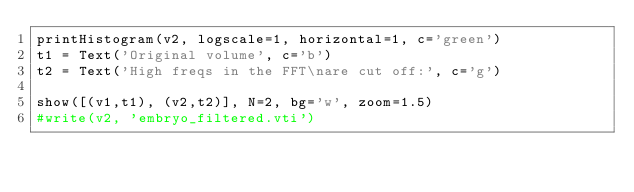<code> <loc_0><loc_0><loc_500><loc_500><_Python_>printHistogram(v2, logscale=1, horizontal=1, c='green')
t1 = Text('Original volume', c='b')
t2 = Text('High freqs in the FFT\nare cut off:', c='g')

show([(v1,t1), (v2,t2)], N=2, bg='w', zoom=1.5)
#write(v2, 'embryo_filtered.vti')
</code> 